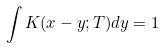Convert formula to latex. <formula><loc_0><loc_0><loc_500><loc_500>\int K ( x - y ; T ) d y = 1</formula> 